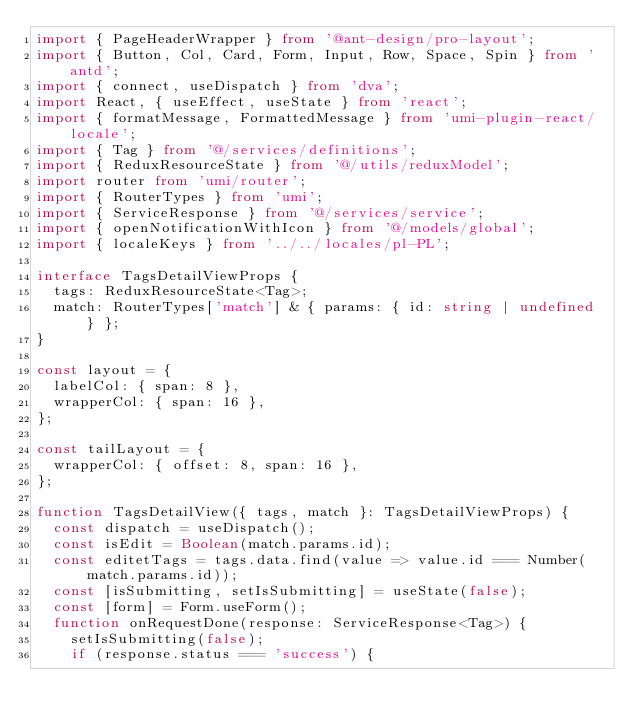Convert code to text. <code><loc_0><loc_0><loc_500><loc_500><_TypeScript_>import { PageHeaderWrapper } from '@ant-design/pro-layout';
import { Button, Col, Card, Form, Input, Row, Space, Spin } from 'antd';
import { connect, useDispatch } from 'dva';
import React, { useEffect, useState } from 'react';
import { formatMessage, FormattedMessage } from 'umi-plugin-react/locale';
import { Tag } from '@/services/definitions';
import { ReduxResourceState } from '@/utils/reduxModel';
import router from 'umi/router';
import { RouterTypes } from 'umi';
import { ServiceResponse } from '@/services/service';
import { openNotificationWithIcon } from '@/models/global';
import { localeKeys } from '../../locales/pl-PL';

interface TagsDetailViewProps {
  tags: ReduxResourceState<Tag>;
  match: RouterTypes['match'] & { params: { id: string | undefined } };
}

const layout = {
  labelCol: { span: 8 },
  wrapperCol: { span: 16 },
};

const tailLayout = {
  wrapperCol: { offset: 8, span: 16 },
};

function TagsDetailView({ tags, match }: TagsDetailViewProps) {
  const dispatch = useDispatch();
  const isEdit = Boolean(match.params.id);
  const editetTags = tags.data.find(value => value.id === Number(match.params.id));
  const [isSubmitting, setIsSubmitting] = useState(false);
  const [form] = Form.useForm();
  function onRequestDone(response: ServiceResponse<Tag>) {
    setIsSubmitting(false);
    if (response.status === 'success') {</code> 